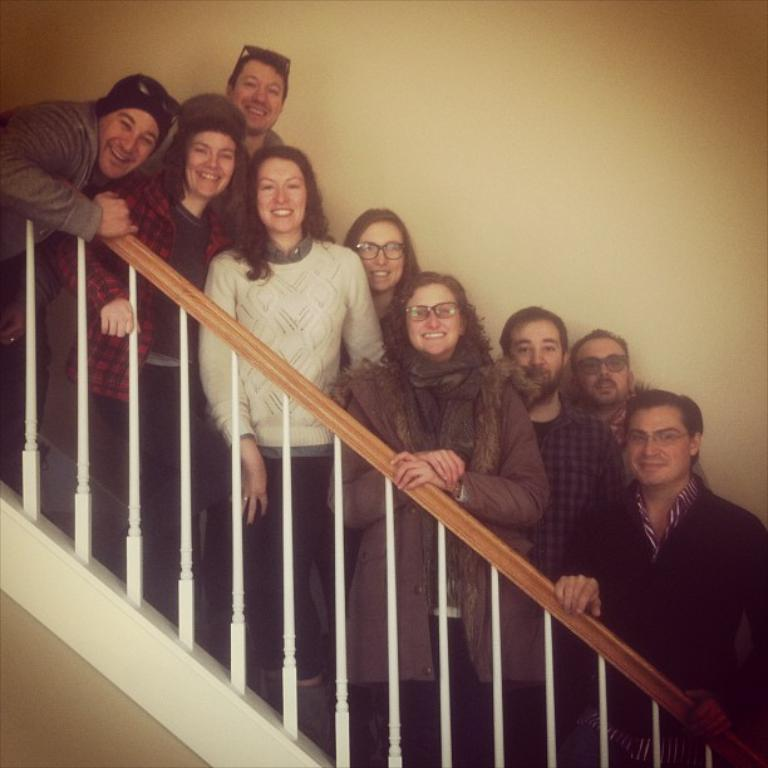What can be seen in the foreground of the image? There are persons standing in front of the fence. What is the color of the wall visible in the background? The wall visible in the background is white. Where is the sink located in the image? There is no sink present in the image. What type of lock is used on the fence in the image? There is no lock visible on the fence in the image. 